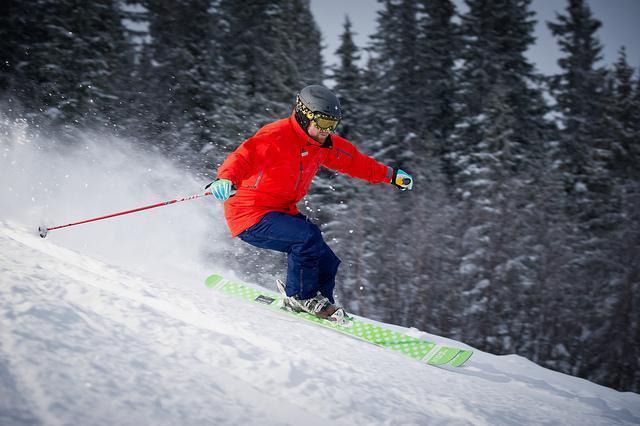What color is the snow jacket worn by the skier?
Choose the right answer from the provided options to respond to the question.
Options: Green, blue, orange, yellow. Orange. 